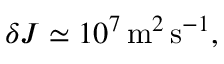Convert formula to latex. <formula><loc_0><loc_0><loc_500><loc_500>\delta J \simeq 1 0 ^ { 7 } \, m ^ { 2 } \, s ^ { - 1 } ,</formula> 